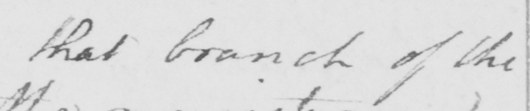What does this handwritten line say? that branch of the 